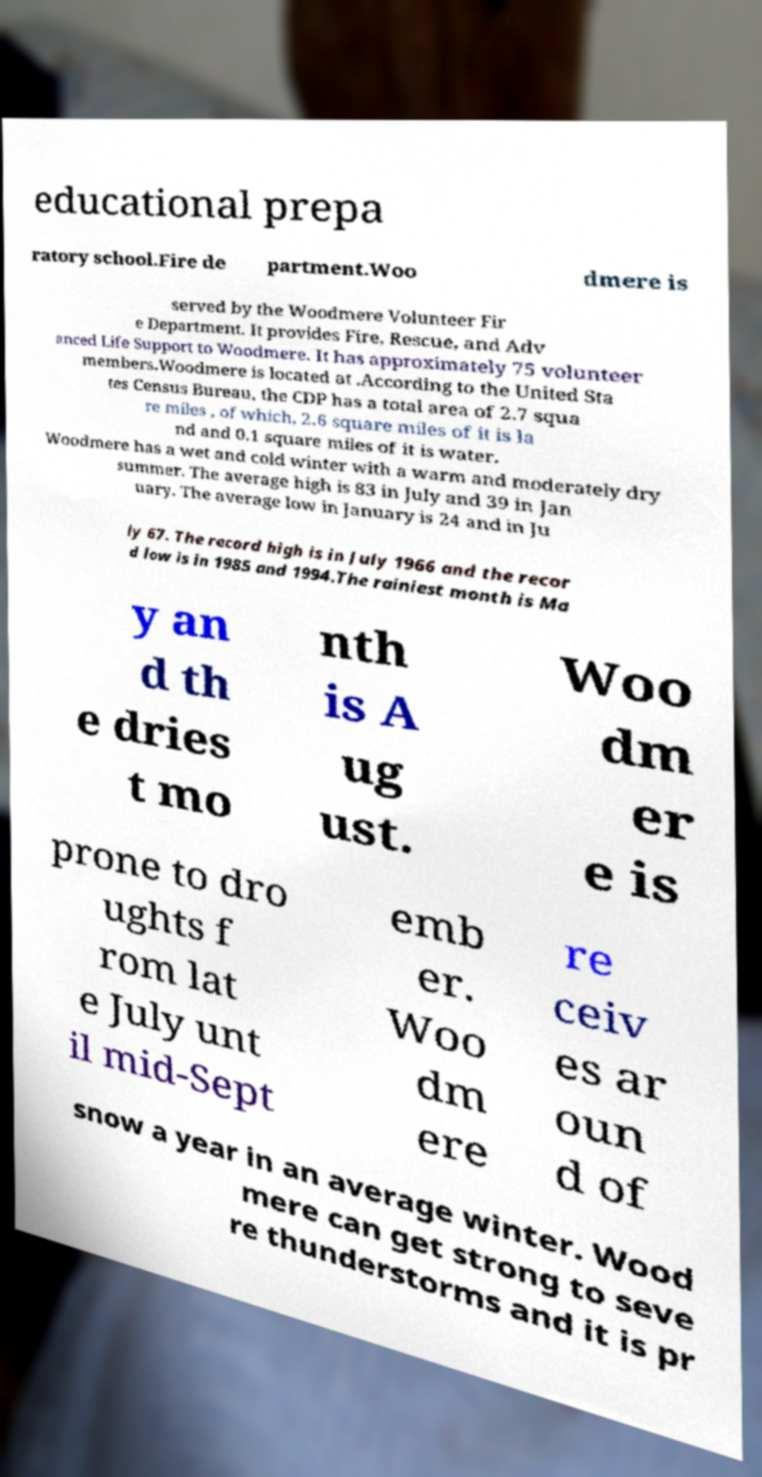Could you assist in decoding the text presented in this image and type it out clearly? educational prepa ratory school.Fire de partment.Woo dmere is served by the Woodmere Volunteer Fir e Department. It provides Fire, Rescue, and Adv anced Life Support to Woodmere. It has approximately 75 volunteer members.Woodmere is located at .According to the United Sta tes Census Bureau, the CDP has a total area of 2.7 squa re miles , of which, 2.6 square miles of it is la nd and 0.1 square miles of it is water. Woodmere has a wet and cold winter with a warm and moderately dry summer. The average high is 83 in July and 39 in Jan uary. The average low in January is 24 and in Ju ly 67. The record high is in July 1966 and the recor d low is in 1985 and 1994.The rainiest month is Ma y an d th e dries t mo nth is A ug ust. Woo dm er e is prone to dro ughts f rom lat e July unt il mid-Sept emb er. Woo dm ere re ceiv es ar oun d of snow a year in an average winter. Wood mere can get strong to seve re thunderstorms and it is pr 